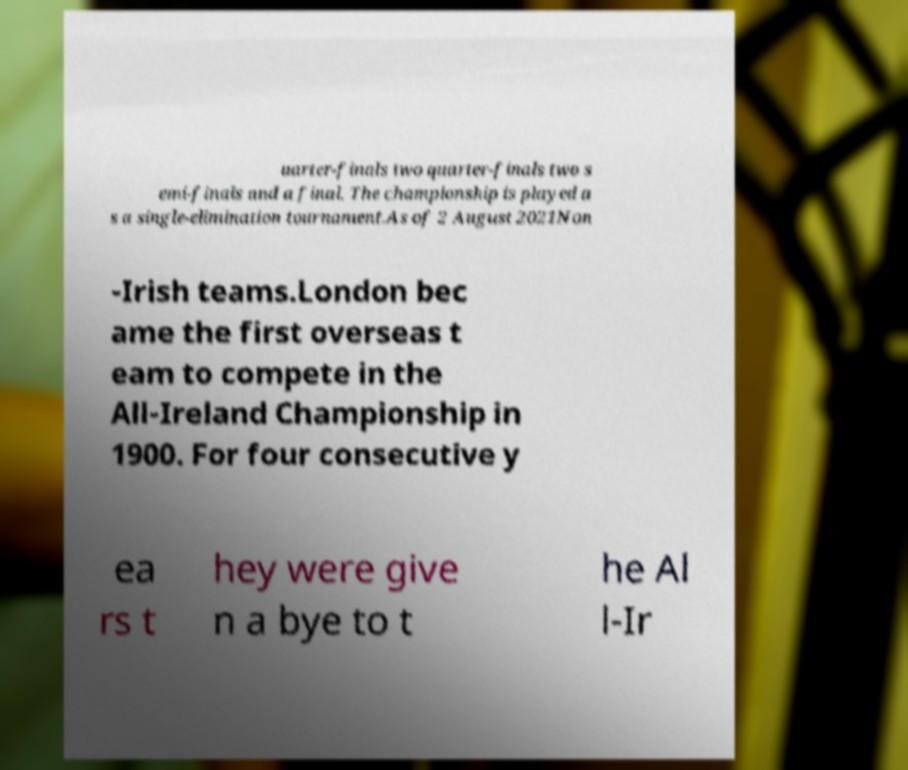Can you accurately transcribe the text from the provided image for me? uarter-finals two quarter-finals two s emi-finals and a final. The championship is played a s a single-elimination tournament.As of 2 August 2021Non -Irish teams.London bec ame the first overseas t eam to compete in the All-Ireland Championship in 1900. For four consecutive y ea rs t hey were give n a bye to t he Al l-Ir 